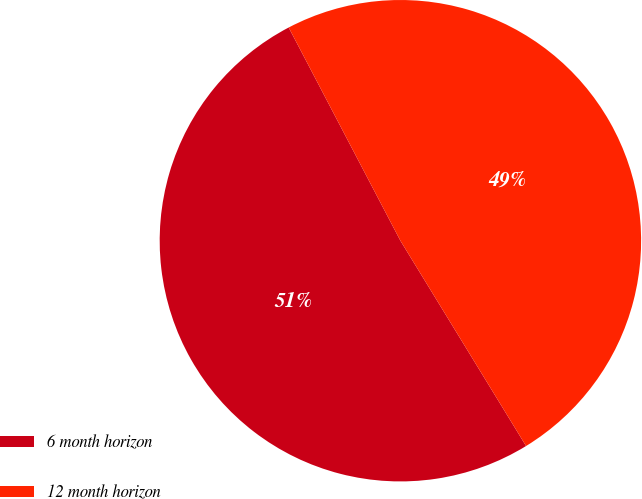<chart> <loc_0><loc_0><loc_500><loc_500><pie_chart><fcel>6 month horizon<fcel>12 month horizon<nl><fcel>51.06%<fcel>48.94%<nl></chart> 